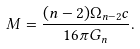<formula> <loc_0><loc_0><loc_500><loc_500>M = \frac { ( n - 2 ) \Omega _ { n - 2 } c } { 1 6 \pi G _ { n } } .</formula> 